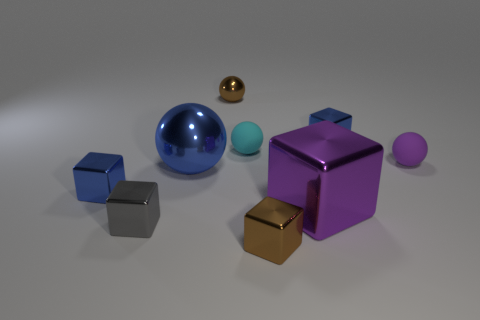How big is the purple object to the left of the blue thing that is on the right side of the purple metallic object?
Make the answer very short. Large. The cyan matte thing has what size?
Make the answer very short. Small. There is a big shiny thing that is right of the cyan sphere; is it the same color as the tiny rubber ball that is right of the purple cube?
Your answer should be compact. Yes. How many other objects are there of the same material as the large blue thing?
Your response must be concise. 6. Are there any tiny cyan rubber spheres?
Your answer should be very brief. Yes. Do the tiny blue cube on the right side of the gray block and the tiny cyan thing have the same material?
Your response must be concise. No. There is a tiny brown object that is the same shape as the purple shiny thing; what is its material?
Keep it short and to the point. Metal. There is a tiny thing that is the same color as the large block; what is it made of?
Your answer should be very brief. Rubber. Are there fewer big red blocks than brown objects?
Ensure brevity in your answer.  Yes. Is the color of the cube that is on the left side of the gray thing the same as the big sphere?
Provide a succinct answer. Yes. 